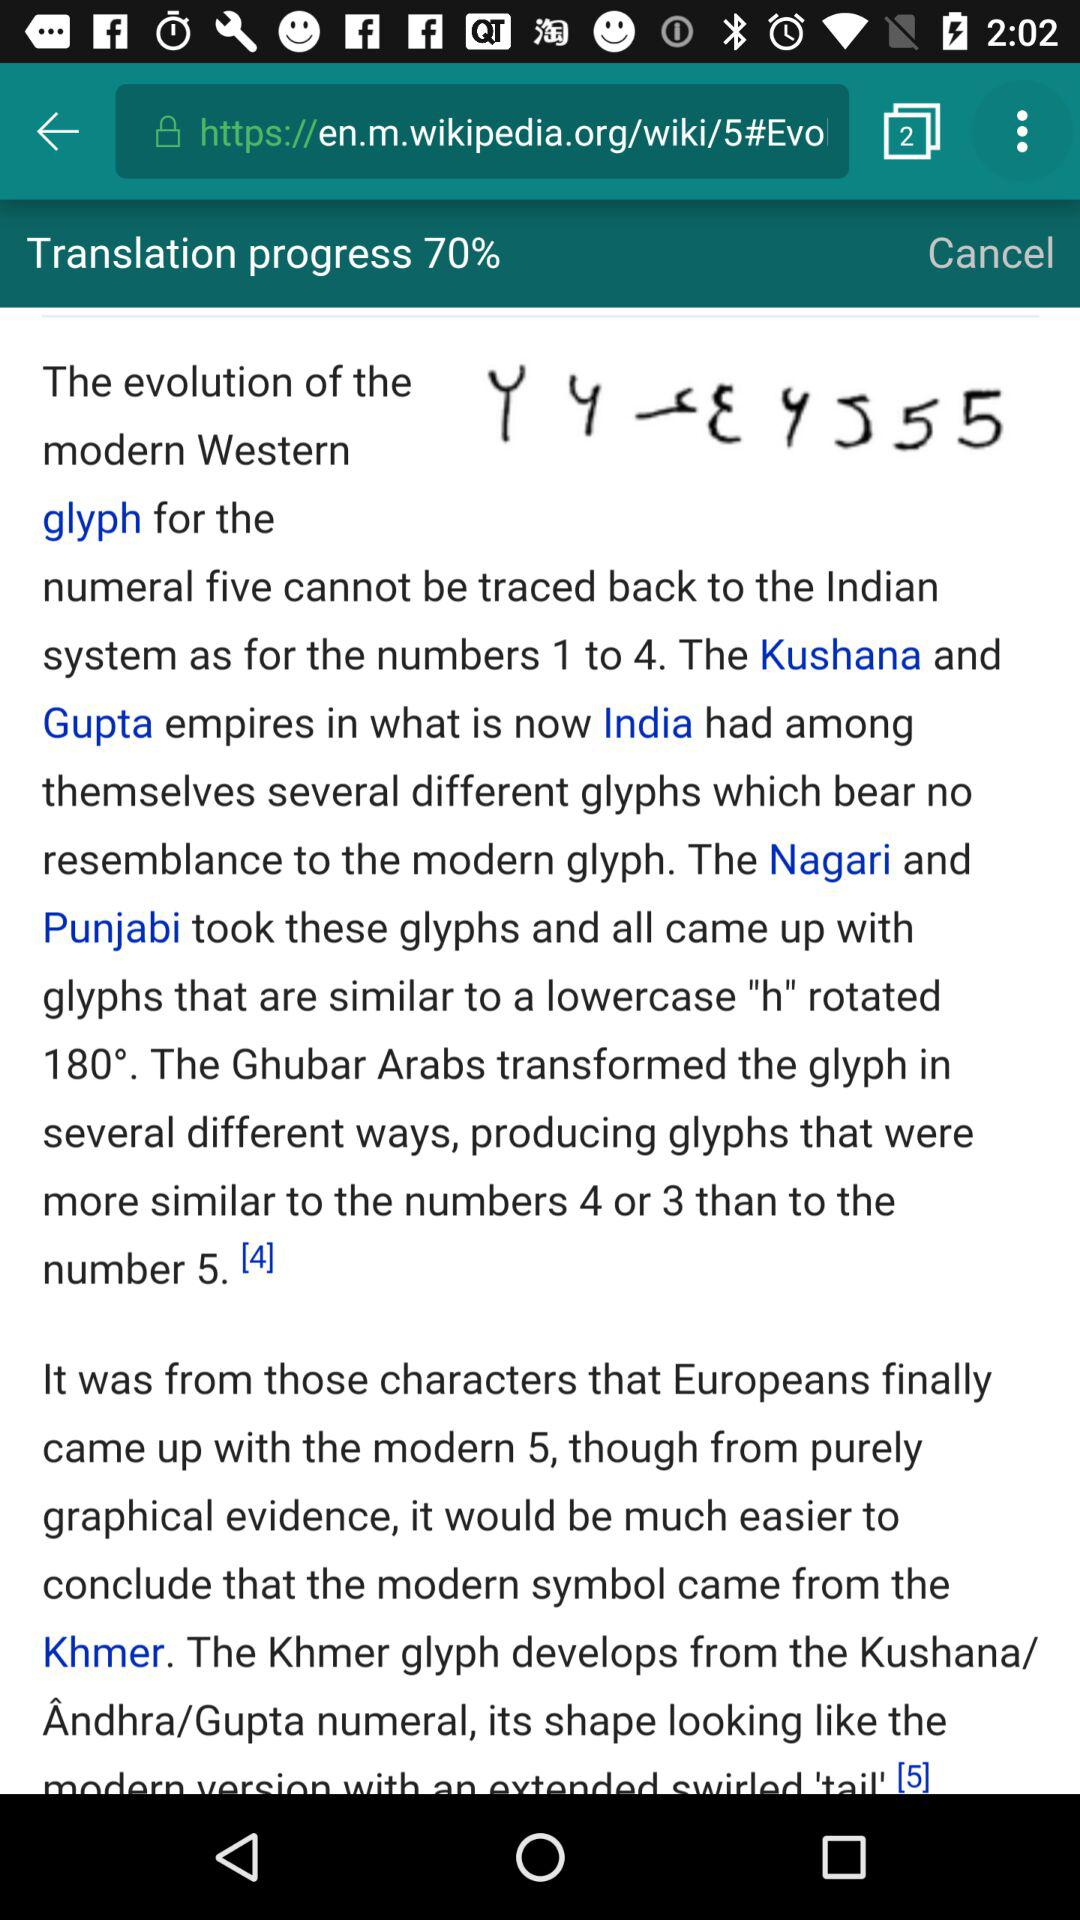What is the name of the application? The name of the application is "DRAFT". 